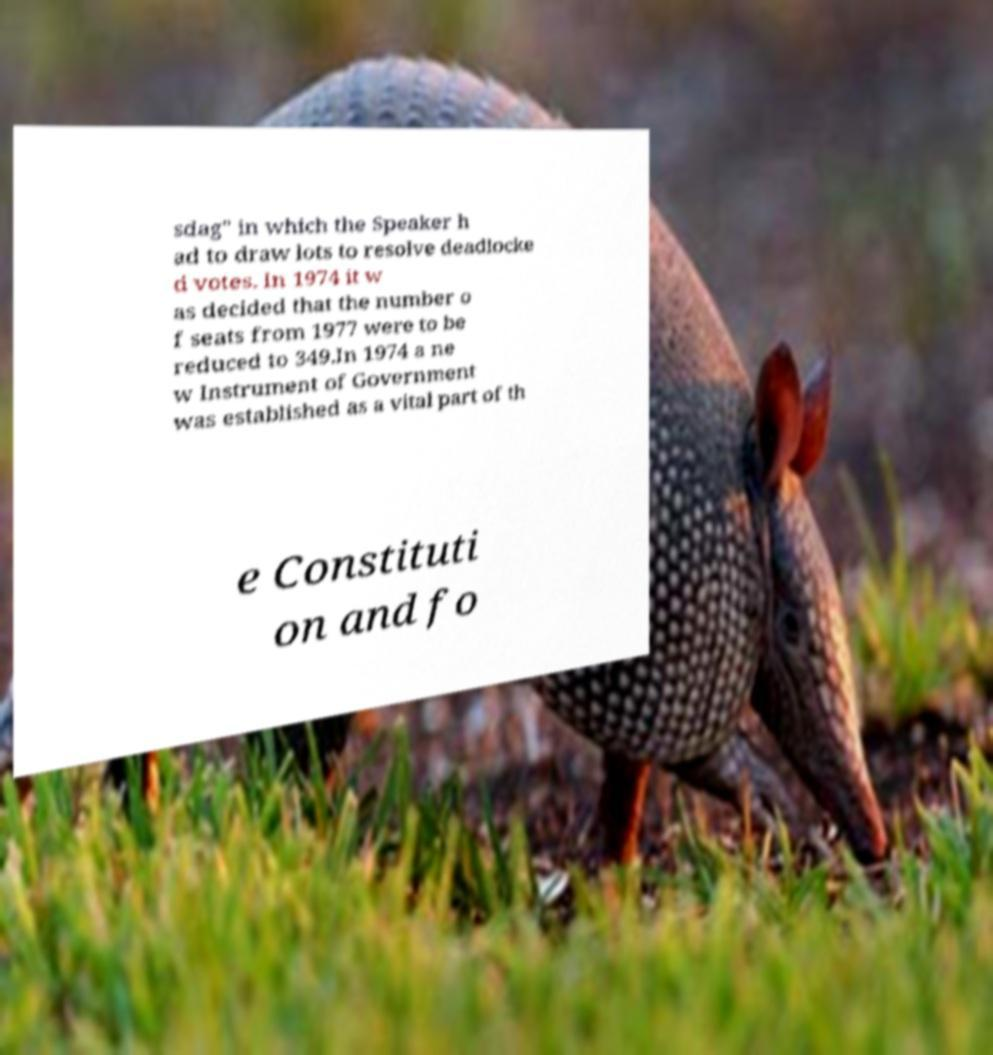There's text embedded in this image that I need extracted. Can you transcribe it verbatim? sdag" in which the Speaker h ad to draw lots to resolve deadlocke d votes. In 1974 it w as decided that the number o f seats from 1977 were to be reduced to 349.In 1974 a ne w Instrument of Government was established as a vital part of th e Constituti on and fo 